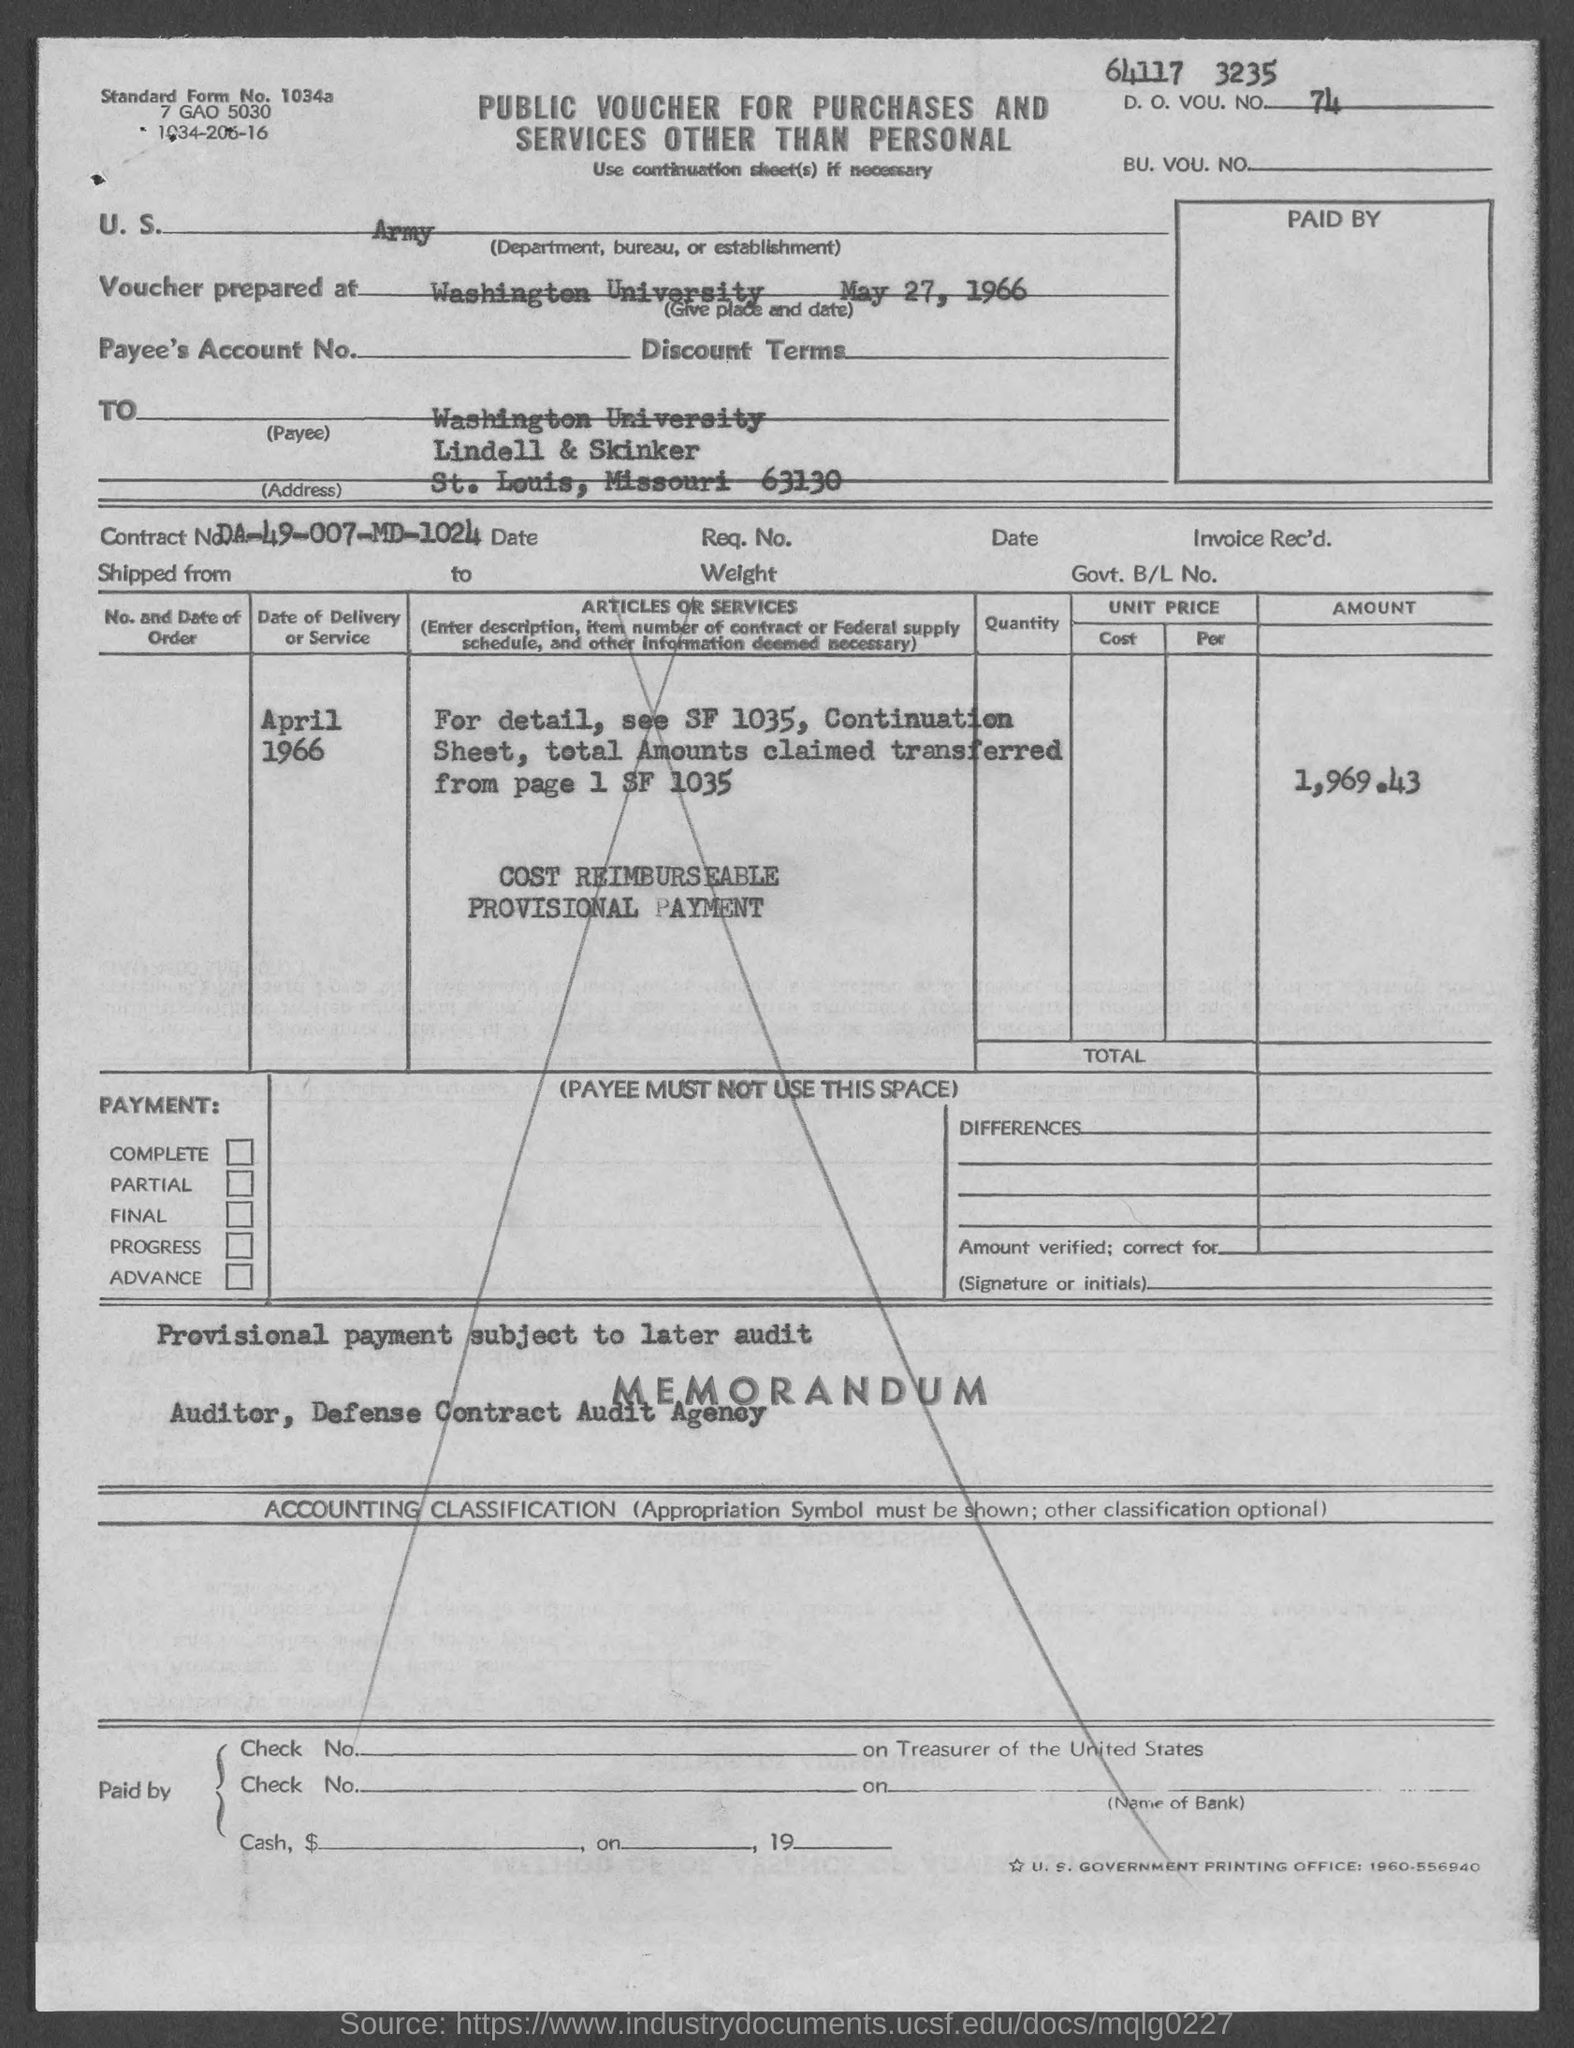Highlight a few significant elements in this photo. What is the DOVONO number? It is 74.. The voucher is prepared at Washington University. 